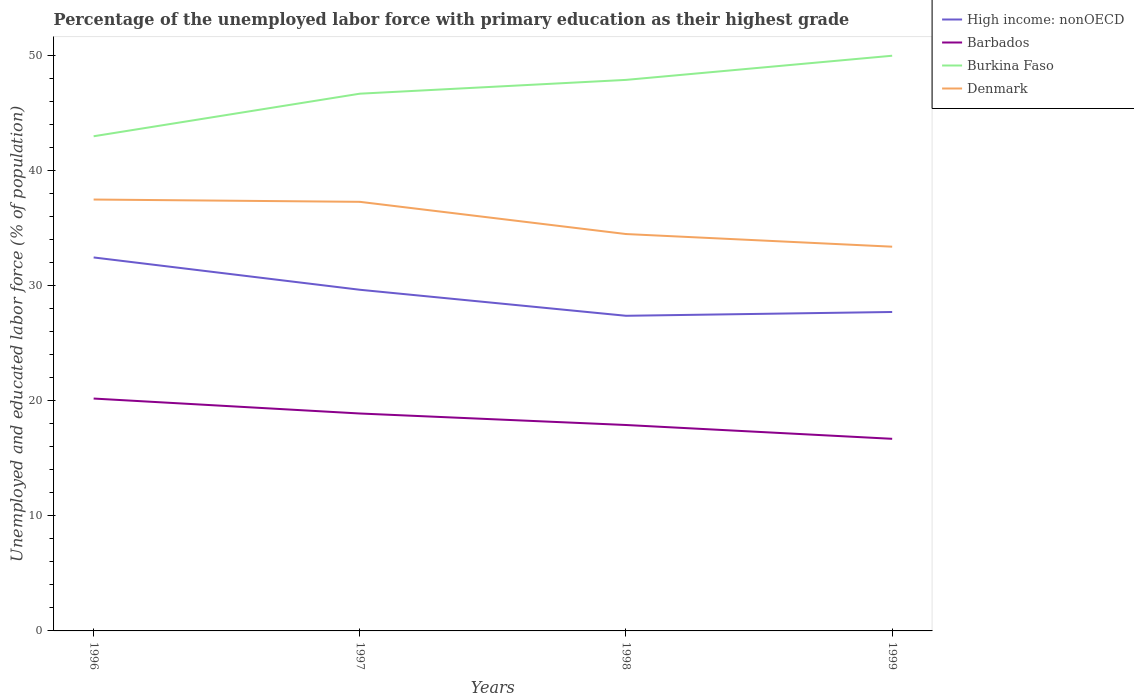How many different coloured lines are there?
Keep it short and to the point. 4. Across all years, what is the maximum percentage of the unemployed labor force with primary education in Denmark?
Offer a very short reply. 33.4. In which year was the percentage of the unemployed labor force with primary education in Barbados maximum?
Your answer should be compact. 1999. What is the total percentage of the unemployed labor force with primary education in Barbados in the graph?
Your answer should be very brief. 1.3. Is the percentage of the unemployed labor force with primary education in High income: nonOECD strictly greater than the percentage of the unemployed labor force with primary education in Denmark over the years?
Your answer should be very brief. Yes. How many lines are there?
Keep it short and to the point. 4. What is the difference between two consecutive major ticks on the Y-axis?
Offer a very short reply. 10. Are the values on the major ticks of Y-axis written in scientific E-notation?
Your answer should be compact. No. How many legend labels are there?
Offer a very short reply. 4. How are the legend labels stacked?
Ensure brevity in your answer.  Vertical. What is the title of the graph?
Your answer should be very brief. Percentage of the unemployed labor force with primary education as their highest grade. Does "New Caledonia" appear as one of the legend labels in the graph?
Offer a terse response. No. What is the label or title of the X-axis?
Offer a very short reply. Years. What is the label or title of the Y-axis?
Make the answer very short. Unemployed and educated labor force (% of population). What is the Unemployed and educated labor force (% of population) of High income: nonOECD in 1996?
Give a very brief answer. 32.47. What is the Unemployed and educated labor force (% of population) of Barbados in 1996?
Your answer should be very brief. 20.2. What is the Unemployed and educated labor force (% of population) of Burkina Faso in 1996?
Provide a short and direct response. 43. What is the Unemployed and educated labor force (% of population) in Denmark in 1996?
Provide a succinct answer. 37.5. What is the Unemployed and educated labor force (% of population) of High income: nonOECD in 1997?
Your answer should be compact. 29.66. What is the Unemployed and educated labor force (% of population) in Barbados in 1997?
Keep it short and to the point. 18.9. What is the Unemployed and educated labor force (% of population) in Burkina Faso in 1997?
Offer a terse response. 46.7. What is the Unemployed and educated labor force (% of population) of Denmark in 1997?
Provide a short and direct response. 37.3. What is the Unemployed and educated labor force (% of population) of High income: nonOECD in 1998?
Your answer should be compact. 27.39. What is the Unemployed and educated labor force (% of population) in Barbados in 1998?
Your response must be concise. 17.9. What is the Unemployed and educated labor force (% of population) in Burkina Faso in 1998?
Provide a succinct answer. 47.9. What is the Unemployed and educated labor force (% of population) in Denmark in 1998?
Offer a very short reply. 34.5. What is the Unemployed and educated labor force (% of population) of High income: nonOECD in 1999?
Make the answer very short. 27.72. What is the Unemployed and educated labor force (% of population) of Barbados in 1999?
Give a very brief answer. 16.7. What is the Unemployed and educated labor force (% of population) in Burkina Faso in 1999?
Offer a terse response. 50. What is the Unemployed and educated labor force (% of population) of Denmark in 1999?
Your answer should be compact. 33.4. Across all years, what is the maximum Unemployed and educated labor force (% of population) of High income: nonOECD?
Make the answer very short. 32.47. Across all years, what is the maximum Unemployed and educated labor force (% of population) in Barbados?
Ensure brevity in your answer.  20.2. Across all years, what is the maximum Unemployed and educated labor force (% of population) of Denmark?
Give a very brief answer. 37.5. Across all years, what is the minimum Unemployed and educated labor force (% of population) in High income: nonOECD?
Provide a short and direct response. 27.39. Across all years, what is the minimum Unemployed and educated labor force (% of population) of Barbados?
Offer a very short reply. 16.7. Across all years, what is the minimum Unemployed and educated labor force (% of population) of Denmark?
Provide a succinct answer. 33.4. What is the total Unemployed and educated labor force (% of population) of High income: nonOECD in the graph?
Your answer should be compact. 117.24. What is the total Unemployed and educated labor force (% of population) of Barbados in the graph?
Provide a short and direct response. 73.7. What is the total Unemployed and educated labor force (% of population) in Burkina Faso in the graph?
Ensure brevity in your answer.  187.6. What is the total Unemployed and educated labor force (% of population) of Denmark in the graph?
Provide a succinct answer. 142.7. What is the difference between the Unemployed and educated labor force (% of population) of High income: nonOECD in 1996 and that in 1997?
Give a very brief answer. 2.81. What is the difference between the Unemployed and educated labor force (% of population) in Barbados in 1996 and that in 1997?
Your response must be concise. 1.3. What is the difference between the Unemployed and educated labor force (% of population) in Burkina Faso in 1996 and that in 1997?
Provide a succinct answer. -3.7. What is the difference between the Unemployed and educated labor force (% of population) of Denmark in 1996 and that in 1997?
Your answer should be very brief. 0.2. What is the difference between the Unemployed and educated labor force (% of population) in High income: nonOECD in 1996 and that in 1998?
Make the answer very short. 5.07. What is the difference between the Unemployed and educated labor force (% of population) in Burkina Faso in 1996 and that in 1998?
Your answer should be very brief. -4.9. What is the difference between the Unemployed and educated labor force (% of population) of Denmark in 1996 and that in 1998?
Ensure brevity in your answer.  3. What is the difference between the Unemployed and educated labor force (% of population) of High income: nonOECD in 1996 and that in 1999?
Keep it short and to the point. 4.74. What is the difference between the Unemployed and educated labor force (% of population) in Burkina Faso in 1996 and that in 1999?
Your response must be concise. -7. What is the difference between the Unemployed and educated labor force (% of population) in Denmark in 1996 and that in 1999?
Offer a terse response. 4.1. What is the difference between the Unemployed and educated labor force (% of population) in High income: nonOECD in 1997 and that in 1998?
Offer a very short reply. 2.26. What is the difference between the Unemployed and educated labor force (% of population) of Barbados in 1997 and that in 1998?
Your response must be concise. 1. What is the difference between the Unemployed and educated labor force (% of population) in Burkina Faso in 1997 and that in 1998?
Offer a terse response. -1.2. What is the difference between the Unemployed and educated labor force (% of population) in High income: nonOECD in 1997 and that in 1999?
Provide a succinct answer. 1.93. What is the difference between the Unemployed and educated labor force (% of population) in Barbados in 1997 and that in 1999?
Your answer should be very brief. 2.2. What is the difference between the Unemployed and educated labor force (% of population) of Burkina Faso in 1997 and that in 1999?
Ensure brevity in your answer.  -3.3. What is the difference between the Unemployed and educated labor force (% of population) of High income: nonOECD in 1998 and that in 1999?
Provide a short and direct response. -0.33. What is the difference between the Unemployed and educated labor force (% of population) of Burkina Faso in 1998 and that in 1999?
Your answer should be compact. -2.1. What is the difference between the Unemployed and educated labor force (% of population) of High income: nonOECD in 1996 and the Unemployed and educated labor force (% of population) of Barbados in 1997?
Make the answer very short. 13.57. What is the difference between the Unemployed and educated labor force (% of population) in High income: nonOECD in 1996 and the Unemployed and educated labor force (% of population) in Burkina Faso in 1997?
Provide a short and direct response. -14.23. What is the difference between the Unemployed and educated labor force (% of population) in High income: nonOECD in 1996 and the Unemployed and educated labor force (% of population) in Denmark in 1997?
Keep it short and to the point. -4.83. What is the difference between the Unemployed and educated labor force (% of population) in Barbados in 1996 and the Unemployed and educated labor force (% of population) in Burkina Faso in 1997?
Provide a short and direct response. -26.5. What is the difference between the Unemployed and educated labor force (% of population) of Barbados in 1996 and the Unemployed and educated labor force (% of population) of Denmark in 1997?
Your answer should be very brief. -17.1. What is the difference between the Unemployed and educated labor force (% of population) of Burkina Faso in 1996 and the Unemployed and educated labor force (% of population) of Denmark in 1997?
Give a very brief answer. 5.7. What is the difference between the Unemployed and educated labor force (% of population) in High income: nonOECD in 1996 and the Unemployed and educated labor force (% of population) in Barbados in 1998?
Offer a terse response. 14.57. What is the difference between the Unemployed and educated labor force (% of population) in High income: nonOECD in 1996 and the Unemployed and educated labor force (% of population) in Burkina Faso in 1998?
Keep it short and to the point. -15.43. What is the difference between the Unemployed and educated labor force (% of population) in High income: nonOECD in 1996 and the Unemployed and educated labor force (% of population) in Denmark in 1998?
Keep it short and to the point. -2.03. What is the difference between the Unemployed and educated labor force (% of population) of Barbados in 1996 and the Unemployed and educated labor force (% of population) of Burkina Faso in 1998?
Offer a very short reply. -27.7. What is the difference between the Unemployed and educated labor force (% of population) of Barbados in 1996 and the Unemployed and educated labor force (% of population) of Denmark in 1998?
Provide a short and direct response. -14.3. What is the difference between the Unemployed and educated labor force (% of population) in Burkina Faso in 1996 and the Unemployed and educated labor force (% of population) in Denmark in 1998?
Ensure brevity in your answer.  8.5. What is the difference between the Unemployed and educated labor force (% of population) in High income: nonOECD in 1996 and the Unemployed and educated labor force (% of population) in Barbados in 1999?
Ensure brevity in your answer.  15.77. What is the difference between the Unemployed and educated labor force (% of population) of High income: nonOECD in 1996 and the Unemployed and educated labor force (% of population) of Burkina Faso in 1999?
Provide a short and direct response. -17.53. What is the difference between the Unemployed and educated labor force (% of population) of High income: nonOECD in 1996 and the Unemployed and educated labor force (% of population) of Denmark in 1999?
Your response must be concise. -0.93. What is the difference between the Unemployed and educated labor force (% of population) in Barbados in 1996 and the Unemployed and educated labor force (% of population) in Burkina Faso in 1999?
Ensure brevity in your answer.  -29.8. What is the difference between the Unemployed and educated labor force (% of population) of Barbados in 1996 and the Unemployed and educated labor force (% of population) of Denmark in 1999?
Offer a very short reply. -13.2. What is the difference between the Unemployed and educated labor force (% of population) in High income: nonOECD in 1997 and the Unemployed and educated labor force (% of population) in Barbados in 1998?
Keep it short and to the point. 11.76. What is the difference between the Unemployed and educated labor force (% of population) of High income: nonOECD in 1997 and the Unemployed and educated labor force (% of population) of Burkina Faso in 1998?
Provide a short and direct response. -18.24. What is the difference between the Unemployed and educated labor force (% of population) in High income: nonOECD in 1997 and the Unemployed and educated labor force (% of population) in Denmark in 1998?
Keep it short and to the point. -4.84. What is the difference between the Unemployed and educated labor force (% of population) of Barbados in 1997 and the Unemployed and educated labor force (% of population) of Burkina Faso in 1998?
Keep it short and to the point. -29. What is the difference between the Unemployed and educated labor force (% of population) in Barbados in 1997 and the Unemployed and educated labor force (% of population) in Denmark in 1998?
Make the answer very short. -15.6. What is the difference between the Unemployed and educated labor force (% of population) in Burkina Faso in 1997 and the Unemployed and educated labor force (% of population) in Denmark in 1998?
Your response must be concise. 12.2. What is the difference between the Unemployed and educated labor force (% of population) in High income: nonOECD in 1997 and the Unemployed and educated labor force (% of population) in Barbados in 1999?
Give a very brief answer. 12.96. What is the difference between the Unemployed and educated labor force (% of population) of High income: nonOECD in 1997 and the Unemployed and educated labor force (% of population) of Burkina Faso in 1999?
Your answer should be compact. -20.34. What is the difference between the Unemployed and educated labor force (% of population) of High income: nonOECD in 1997 and the Unemployed and educated labor force (% of population) of Denmark in 1999?
Offer a terse response. -3.74. What is the difference between the Unemployed and educated labor force (% of population) of Barbados in 1997 and the Unemployed and educated labor force (% of population) of Burkina Faso in 1999?
Give a very brief answer. -31.1. What is the difference between the Unemployed and educated labor force (% of population) of Barbados in 1997 and the Unemployed and educated labor force (% of population) of Denmark in 1999?
Your answer should be very brief. -14.5. What is the difference between the Unemployed and educated labor force (% of population) of Burkina Faso in 1997 and the Unemployed and educated labor force (% of population) of Denmark in 1999?
Keep it short and to the point. 13.3. What is the difference between the Unemployed and educated labor force (% of population) of High income: nonOECD in 1998 and the Unemployed and educated labor force (% of population) of Barbados in 1999?
Ensure brevity in your answer.  10.69. What is the difference between the Unemployed and educated labor force (% of population) in High income: nonOECD in 1998 and the Unemployed and educated labor force (% of population) in Burkina Faso in 1999?
Make the answer very short. -22.61. What is the difference between the Unemployed and educated labor force (% of population) in High income: nonOECD in 1998 and the Unemployed and educated labor force (% of population) in Denmark in 1999?
Your answer should be compact. -6.01. What is the difference between the Unemployed and educated labor force (% of population) of Barbados in 1998 and the Unemployed and educated labor force (% of population) of Burkina Faso in 1999?
Your answer should be very brief. -32.1. What is the difference between the Unemployed and educated labor force (% of population) of Barbados in 1998 and the Unemployed and educated labor force (% of population) of Denmark in 1999?
Your answer should be compact. -15.5. What is the average Unemployed and educated labor force (% of population) of High income: nonOECD per year?
Provide a short and direct response. 29.31. What is the average Unemployed and educated labor force (% of population) of Barbados per year?
Ensure brevity in your answer.  18.43. What is the average Unemployed and educated labor force (% of population) of Burkina Faso per year?
Keep it short and to the point. 46.9. What is the average Unemployed and educated labor force (% of population) in Denmark per year?
Ensure brevity in your answer.  35.67. In the year 1996, what is the difference between the Unemployed and educated labor force (% of population) in High income: nonOECD and Unemployed and educated labor force (% of population) in Barbados?
Ensure brevity in your answer.  12.27. In the year 1996, what is the difference between the Unemployed and educated labor force (% of population) of High income: nonOECD and Unemployed and educated labor force (% of population) of Burkina Faso?
Provide a short and direct response. -10.53. In the year 1996, what is the difference between the Unemployed and educated labor force (% of population) in High income: nonOECD and Unemployed and educated labor force (% of population) in Denmark?
Provide a short and direct response. -5.03. In the year 1996, what is the difference between the Unemployed and educated labor force (% of population) in Barbados and Unemployed and educated labor force (% of population) in Burkina Faso?
Keep it short and to the point. -22.8. In the year 1996, what is the difference between the Unemployed and educated labor force (% of population) in Barbados and Unemployed and educated labor force (% of population) in Denmark?
Make the answer very short. -17.3. In the year 1997, what is the difference between the Unemployed and educated labor force (% of population) in High income: nonOECD and Unemployed and educated labor force (% of population) in Barbados?
Offer a very short reply. 10.76. In the year 1997, what is the difference between the Unemployed and educated labor force (% of population) in High income: nonOECD and Unemployed and educated labor force (% of population) in Burkina Faso?
Ensure brevity in your answer.  -17.04. In the year 1997, what is the difference between the Unemployed and educated labor force (% of population) of High income: nonOECD and Unemployed and educated labor force (% of population) of Denmark?
Ensure brevity in your answer.  -7.64. In the year 1997, what is the difference between the Unemployed and educated labor force (% of population) in Barbados and Unemployed and educated labor force (% of population) in Burkina Faso?
Provide a short and direct response. -27.8. In the year 1997, what is the difference between the Unemployed and educated labor force (% of population) of Barbados and Unemployed and educated labor force (% of population) of Denmark?
Offer a terse response. -18.4. In the year 1997, what is the difference between the Unemployed and educated labor force (% of population) of Burkina Faso and Unemployed and educated labor force (% of population) of Denmark?
Your response must be concise. 9.4. In the year 1998, what is the difference between the Unemployed and educated labor force (% of population) in High income: nonOECD and Unemployed and educated labor force (% of population) in Barbados?
Your response must be concise. 9.49. In the year 1998, what is the difference between the Unemployed and educated labor force (% of population) of High income: nonOECD and Unemployed and educated labor force (% of population) of Burkina Faso?
Your response must be concise. -20.51. In the year 1998, what is the difference between the Unemployed and educated labor force (% of population) of High income: nonOECD and Unemployed and educated labor force (% of population) of Denmark?
Your answer should be very brief. -7.11. In the year 1998, what is the difference between the Unemployed and educated labor force (% of population) of Barbados and Unemployed and educated labor force (% of population) of Denmark?
Offer a very short reply. -16.6. In the year 1999, what is the difference between the Unemployed and educated labor force (% of population) in High income: nonOECD and Unemployed and educated labor force (% of population) in Barbados?
Make the answer very short. 11.02. In the year 1999, what is the difference between the Unemployed and educated labor force (% of population) in High income: nonOECD and Unemployed and educated labor force (% of population) in Burkina Faso?
Provide a succinct answer. -22.28. In the year 1999, what is the difference between the Unemployed and educated labor force (% of population) of High income: nonOECD and Unemployed and educated labor force (% of population) of Denmark?
Your answer should be very brief. -5.68. In the year 1999, what is the difference between the Unemployed and educated labor force (% of population) in Barbados and Unemployed and educated labor force (% of population) in Burkina Faso?
Offer a very short reply. -33.3. In the year 1999, what is the difference between the Unemployed and educated labor force (% of population) of Barbados and Unemployed and educated labor force (% of population) of Denmark?
Offer a very short reply. -16.7. What is the ratio of the Unemployed and educated labor force (% of population) in High income: nonOECD in 1996 to that in 1997?
Provide a succinct answer. 1.09. What is the ratio of the Unemployed and educated labor force (% of population) in Barbados in 1996 to that in 1997?
Provide a succinct answer. 1.07. What is the ratio of the Unemployed and educated labor force (% of population) of Burkina Faso in 1996 to that in 1997?
Provide a short and direct response. 0.92. What is the ratio of the Unemployed and educated labor force (% of population) of Denmark in 1996 to that in 1997?
Give a very brief answer. 1.01. What is the ratio of the Unemployed and educated labor force (% of population) in High income: nonOECD in 1996 to that in 1998?
Give a very brief answer. 1.19. What is the ratio of the Unemployed and educated labor force (% of population) in Barbados in 1996 to that in 1998?
Give a very brief answer. 1.13. What is the ratio of the Unemployed and educated labor force (% of population) in Burkina Faso in 1996 to that in 1998?
Give a very brief answer. 0.9. What is the ratio of the Unemployed and educated labor force (% of population) in Denmark in 1996 to that in 1998?
Provide a short and direct response. 1.09. What is the ratio of the Unemployed and educated labor force (% of population) of High income: nonOECD in 1996 to that in 1999?
Ensure brevity in your answer.  1.17. What is the ratio of the Unemployed and educated labor force (% of population) of Barbados in 1996 to that in 1999?
Keep it short and to the point. 1.21. What is the ratio of the Unemployed and educated labor force (% of population) in Burkina Faso in 1996 to that in 1999?
Ensure brevity in your answer.  0.86. What is the ratio of the Unemployed and educated labor force (% of population) in Denmark in 1996 to that in 1999?
Your response must be concise. 1.12. What is the ratio of the Unemployed and educated labor force (% of population) in High income: nonOECD in 1997 to that in 1998?
Your response must be concise. 1.08. What is the ratio of the Unemployed and educated labor force (% of population) of Barbados in 1997 to that in 1998?
Keep it short and to the point. 1.06. What is the ratio of the Unemployed and educated labor force (% of population) of Burkina Faso in 1997 to that in 1998?
Make the answer very short. 0.97. What is the ratio of the Unemployed and educated labor force (% of population) of Denmark in 1997 to that in 1998?
Offer a terse response. 1.08. What is the ratio of the Unemployed and educated labor force (% of population) in High income: nonOECD in 1997 to that in 1999?
Your response must be concise. 1.07. What is the ratio of the Unemployed and educated labor force (% of population) of Barbados in 1997 to that in 1999?
Keep it short and to the point. 1.13. What is the ratio of the Unemployed and educated labor force (% of population) in Burkina Faso in 1997 to that in 1999?
Make the answer very short. 0.93. What is the ratio of the Unemployed and educated labor force (% of population) in Denmark in 1997 to that in 1999?
Make the answer very short. 1.12. What is the ratio of the Unemployed and educated labor force (% of population) in Barbados in 1998 to that in 1999?
Your answer should be compact. 1.07. What is the ratio of the Unemployed and educated labor force (% of population) in Burkina Faso in 1998 to that in 1999?
Offer a very short reply. 0.96. What is the ratio of the Unemployed and educated labor force (% of population) of Denmark in 1998 to that in 1999?
Keep it short and to the point. 1.03. What is the difference between the highest and the second highest Unemployed and educated labor force (% of population) of High income: nonOECD?
Ensure brevity in your answer.  2.81. What is the difference between the highest and the second highest Unemployed and educated labor force (% of population) in Barbados?
Give a very brief answer. 1.3. What is the difference between the highest and the second highest Unemployed and educated labor force (% of population) in Denmark?
Keep it short and to the point. 0.2. What is the difference between the highest and the lowest Unemployed and educated labor force (% of population) in High income: nonOECD?
Your answer should be very brief. 5.07. What is the difference between the highest and the lowest Unemployed and educated labor force (% of population) in Barbados?
Your response must be concise. 3.5. 